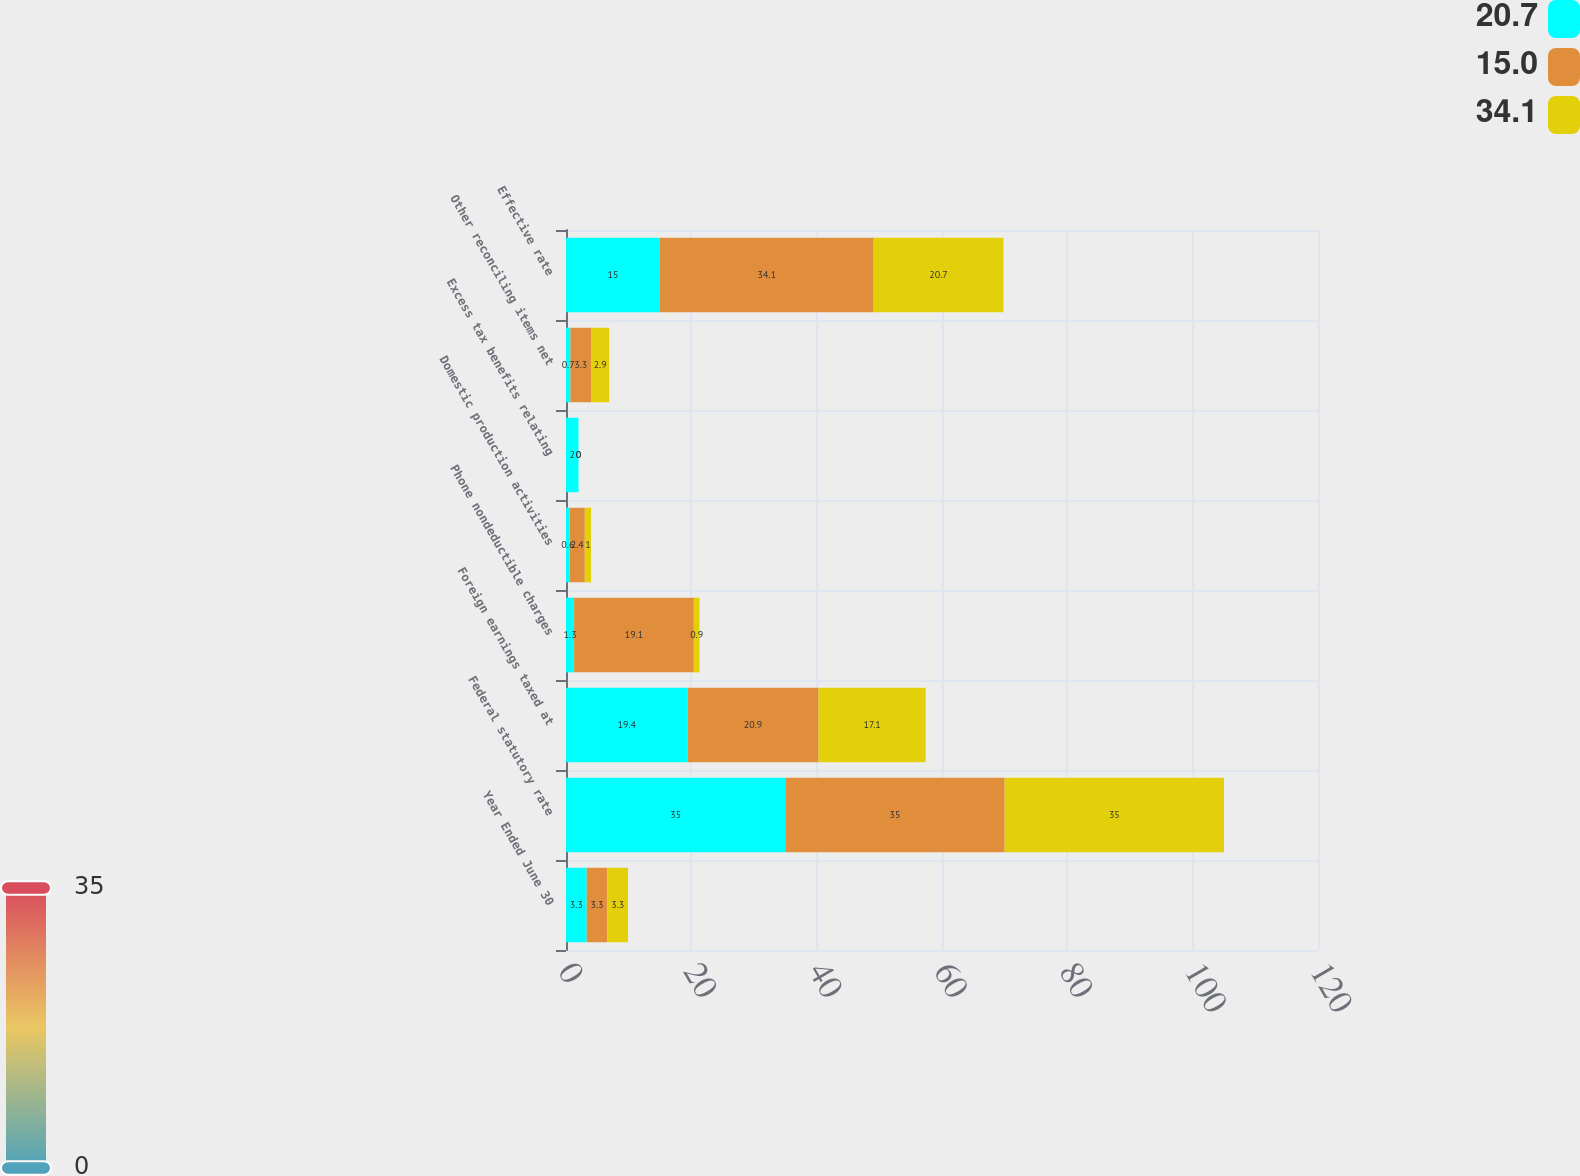Convert chart. <chart><loc_0><loc_0><loc_500><loc_500><stacked_bar_chart><ecel><fcel>Year Ended June 30<fcel>Federal statutory rate<fcel>Foreign earnings taxed at<fcel>Phone nondeductible charges<fcel>Domestic production activities<fcel>Excess tax benefits relating<fcel>Other reconciling items net<fcel>Effective rate<nl><fcel>20.7<fcel>3.3<fcel>35<fcel>19.4<fcel>1.3<fcel>0.6<fcel>2<fcel>0.7<fcel>15<nl><fcel>15<fcel>3.3<fcel>35<fcel>20.9<fcel>19.1<fcel>2.4<fcel>0<fcel>3.3<fcel>34.1<nl><fcel>34.1<fcel>3.3<fcel>35<fcel>17.1<fcel>0.9<fcel>1<fcel>0<fcel>2.9<fcel>20.7<nl></chart> 